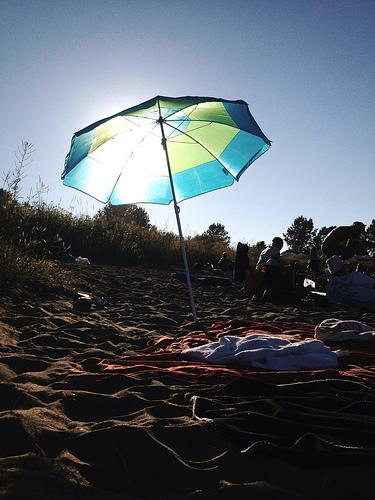Question: what is on the ground?
Choices:
A. Grass.
B. Rocks.
C. Sand.
D. Gravel.
Answer with the letter. Answer: C Question: who is at the beach?
Choices:
A. A woman.
B. A few men.
C. Several teenagers.
D. Some people.
Answer with the letter. Answer: D Question: what lights the scene?
Choices:
A. The sun.
B. The gas lamps.
C. The street lighting.
D. Daylight.
Answer with the letter. Answer: A Question: why does the umbrella look bright?
Choices:
A. It is yellow.
B. The sun is shining through it.
C. Clear plastic.
D. It is made of metal.
Answer with the letter. Answer: B Question: what color is the sky?
Choices:
A. Teal.
B. Purple.
C. Neon.
D. Blue.
Answer with the letter. Answer: D Question: how is the umbrella positioned?
Choices:
A. Standing in the sand.
B. On table.
C. In man hand.
D. In woman hand.
Answer with the letter. Answer: A Question: where is the umbrella?
Choices:
A. On the beach.
B. On patio table.
C. In car.
D. In hand.
Answer with the letter. Answer: A 